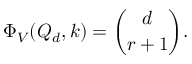Convert formula to latex. <formula><loc_0><loc_0><loc_500><loc_500>\Phi _ { V } ( Q _ { d } , k ) = { \binom { d } { r + 1 } } .</formula> 